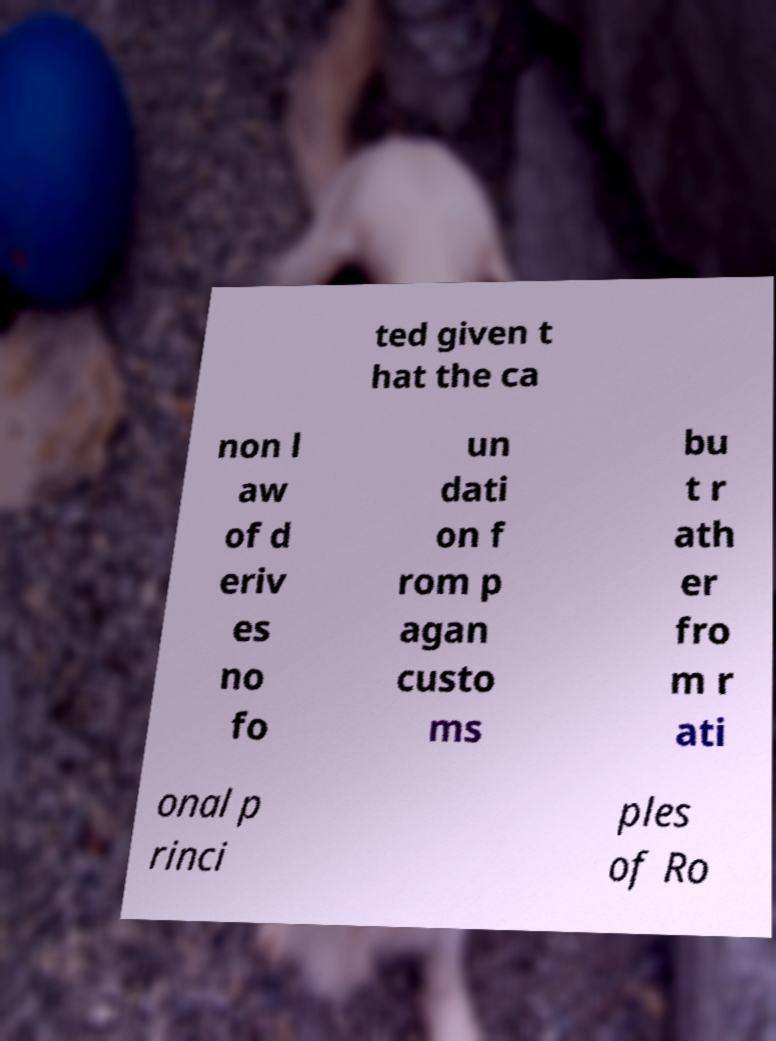Can you read and provide the text displayed in the image?This photo seems to have some interesting text. Can you extract and type it out for me? ted given t hat the ca non l aw of d eriv es no fo un dati on f rom p agan custo ms bu t r ath er fro m r ati onal p rinci ples of Ro 